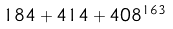<formula> <loc_0><loc_0><loc_500><loc_500>1 8 4 + 4 1 4 + 4 0 8 ^ { 1 6 3 }</formula> 